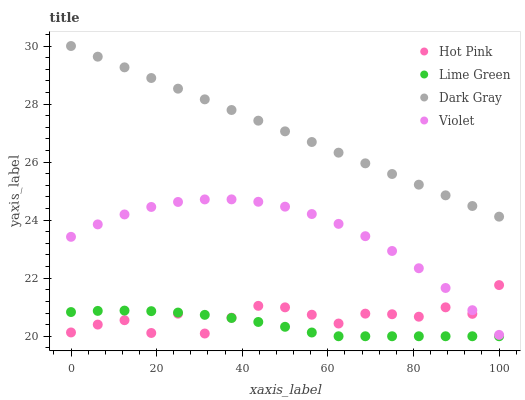Does Lime Green have the minimum area under the curve?
Answer yes or no. Yes. Does Dark Gray have the maximum area under the curve?
Answer yes or no. Yes. Does Hot Pink have the minimum area under the curve?
Answer yes or no. No. Does Hot Pink have the maximum area under the curve?
Answer yes or no. No. Is Dark Gray the smoothest?
Answer yes or no. Yes. Is Hot Pink the roughest?
Answer yes or no. Yes. Is Lime Green the smoothest?
Answer yes or no. No. Is Lime Green the roughest?
Answer yes or no. No. Does Lime Green have the lowest value?
Answer yes or no. Yes. Does Hot Pink have the lowest value?
Answer yes or no. No. Does Dark Gray have the highest value?
Answer yes or no. Yes. Does Hot Pink have the highest value?
Answer yes or no. No. Is Lime Green less than Dark Gray?
Answer yes or no. Yes. Is Dark Gray greater than Hot Pink?
Answer yes or no. Yes. Does Lime Green intersect Hot Pink?
Answer yes or no. Yes. Is Lime Green less than Hot Pink?
Answer yes or no. No. Is Lime Green greater than Hot Pink?
Answer yes or no. No. Does Lime Green intersect Dark Gray?
Answer yes or no. No. 